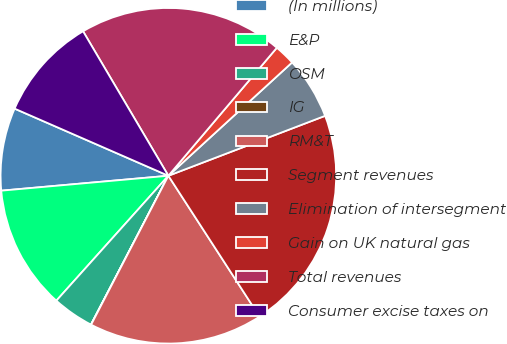Convert chart to OTSL. <chart><loc_0><loc_0><loc_500><loc_500><pie_chart><fcel>(In millions)<fcel>E&P<fcel>OSM<fcel>IG<fcel>RM&T<fcel>Segment revenues<fcel>Elimination of intersegment<fcel>Gain on UK natural gas<fcel>Total revenues<fcel>Consumer excise taxes on<nl><fcel>7.97%<fcel>11.95%<fcel>4.0%<fcel>0.02%<fcel>16.76%<fcel>21.67%<fcel>5.99%<fcel>2.01%<fcel>19.68%<fcel>9.96%<nl></chart> 